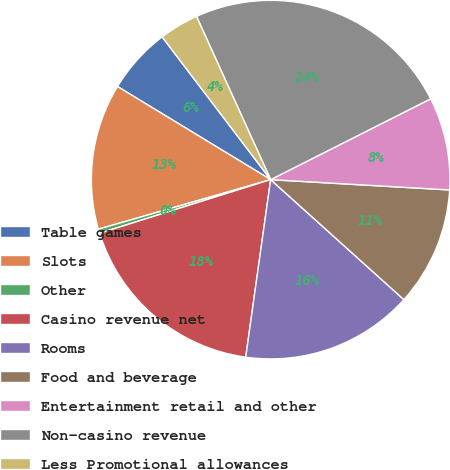Convert chart to OTSL. <chart><loc_0><loc_0><loc_500><loc_500><pie_chart><fcel>Table games<fcel>Slots<fcel>Other<fcel>Casino revenue net<fcel>Rooms<fcel>Food and beverage<fcel>Entertainment retail and other<fcel>Non-casino revenue<fcel>Less Promotional allowances<nl><fcel>5.96%<fcel>13.15%<fcel>0.38%<fcel>17.94%<fcel>15.55%<fcel>10.75%<fcel>8.36%<fcel>24.34%<fcel>3.56%<nl></chart> 